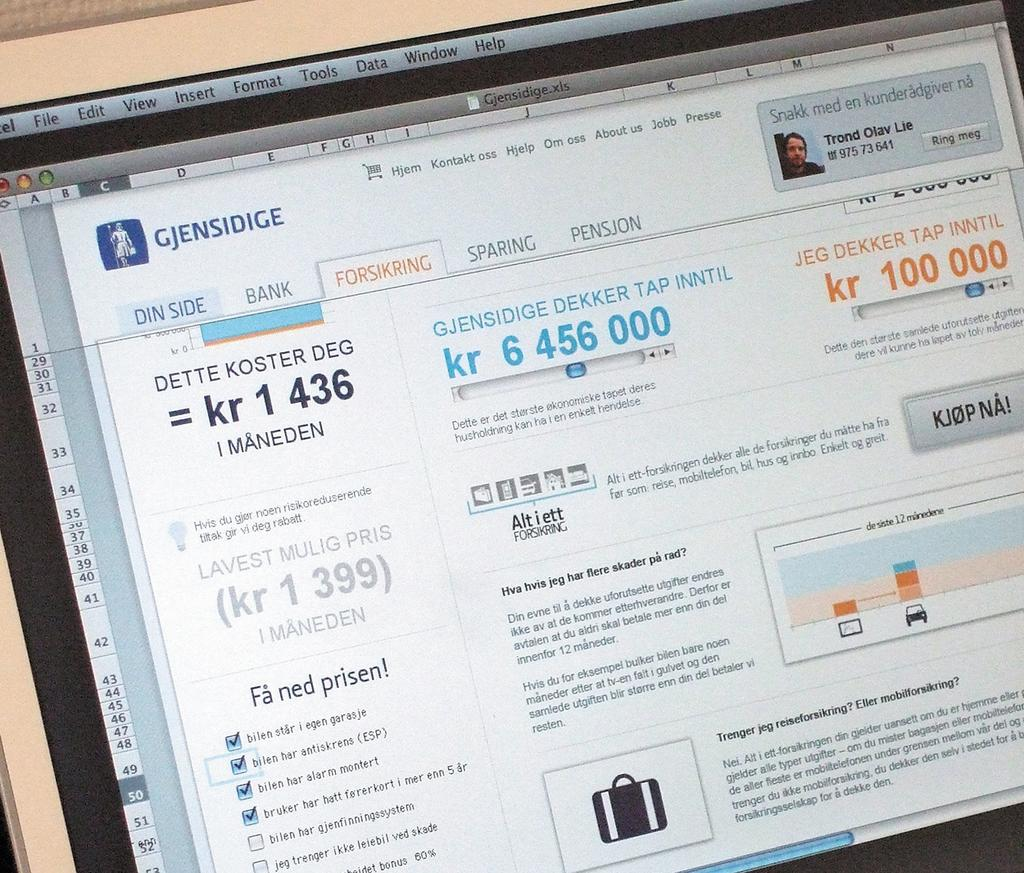<image>
Summarize the visual content of the image. A customer has purchased a ticket on a site called Gjensidige 